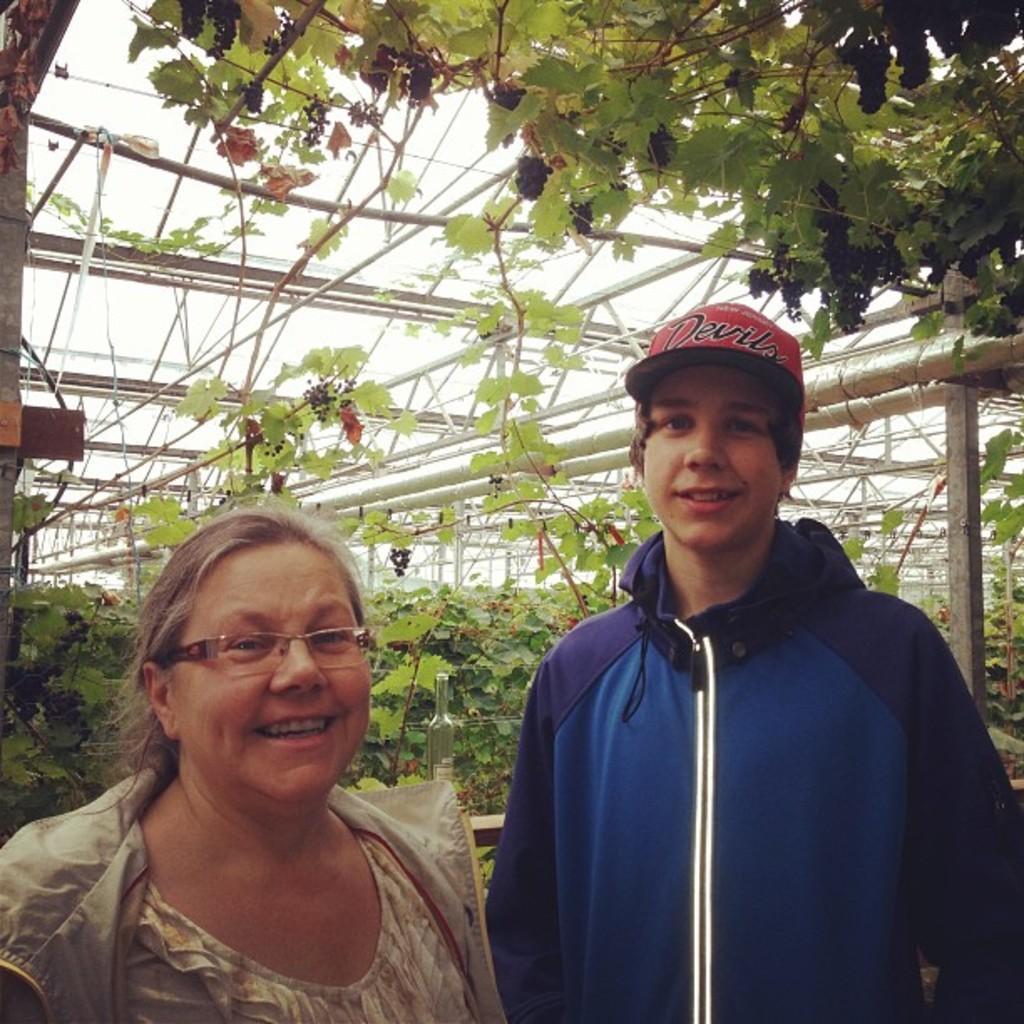In one or two sentences, can you explain what this image depicts? In this image there is a boy and a woman are standing, in the background there are plants and poles. 